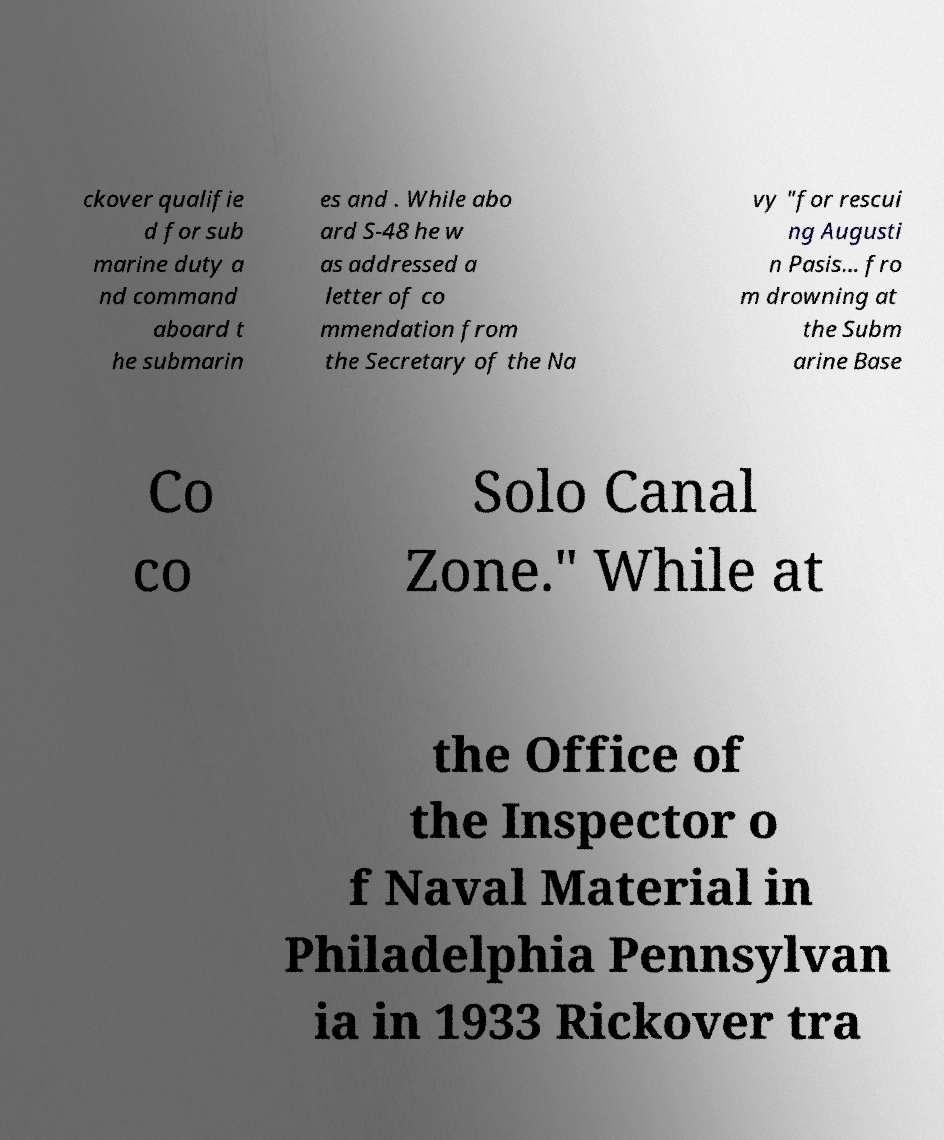What messages or text are displayed in this image? I need them in a readable, typed format. ckover qualifie d for sub marine duty a nd command aboard t he submarin es and . While abo ard S-48 he w as addressed a letter of co mmendation from the Secretary of the Na vy "for rescui ng Augusti n Pasis… fro m drowning at the Subm arine Base Co co Solo Canal Zone." While at the Office of the Inspector o f Naval Material in Philadelphia Pennsylvan ia in 1933 Rickover tra 